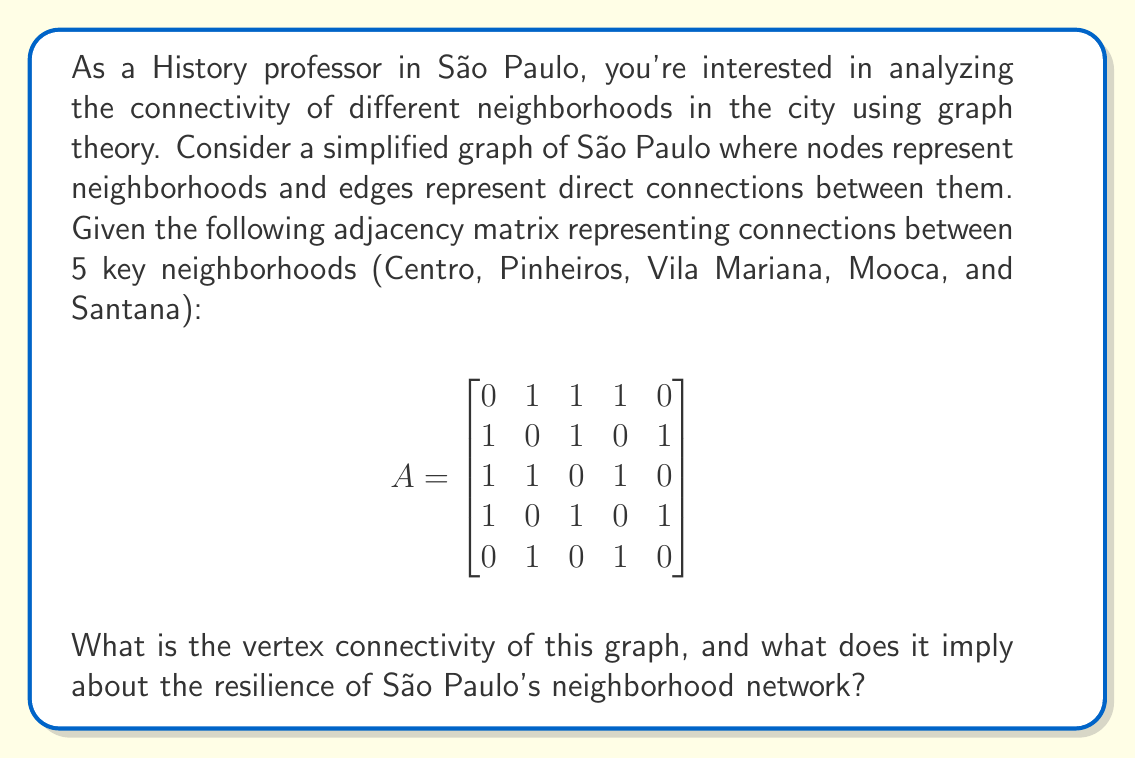Could you help me with this problem? To solve this problem, we need to understand the concept of vertex connectivity and how to calculate it from the given adjacency matrix.

1. Vertex connectivity definition:
   The vertex connectivity of a graph, denoted as $\kappa(G)$, is the minimum number of vertices that need to be removed to disconnect the graph.

2. Analyzing the graph:
   - We have 5 vertices (neighborhoods): Centro, Pinheiros, Vila Mariana, Mooca, and Santana.
   - The adjacency matrix shows the connections between these neighborhoods.

3. Finding the minimum vertex cut:
   - We need to find the smallest set of vertices that, when removed, disconnects the graph.
   - By inspection, we can see that removing any single vertex does not disconnect the graph.
   - However, removing any pair of vertices (except Pinheiros and Mooca) disconnects the graph.

4. Verifying the vertex connectivity:
   - Remove Centro and Vila Mariana:
     This leaves Pinheiros connected to Santana, but Mooca is isolated.
   - Remove Centro and Mooca:
     This leaves Vila Mariana connected to Pinheiros, but Santana is isolated.
   - Other combinations of two vertices also disconnect the graph.

5. Interpreting the result:
   - The vertex connectivity of this graph is 2.
   - This means that at least 2 neighborhoods need to be removed to disconnect the network.

6. Implications for São Paulo's neighborhood network:
   - A vertex connectivity of 2 implies moderate resilience.
   - The network can withstand the loss of any single neighborhood without becoming disconnected.
   - However, strategic removal of two neighborhoods can isolate parts of the city.
   - This suggests that while the network has some robustness, it could benefit from additional connections to increase resilience.
Answer: The vertex connectivity of the graph is 2. This implies that São Paulo's neighborhood network has moderate resilience, able to maintain connectivity if any single neighborhood is removed, but vulnerable to disconnection if two strategic neighborhoods are removed. 